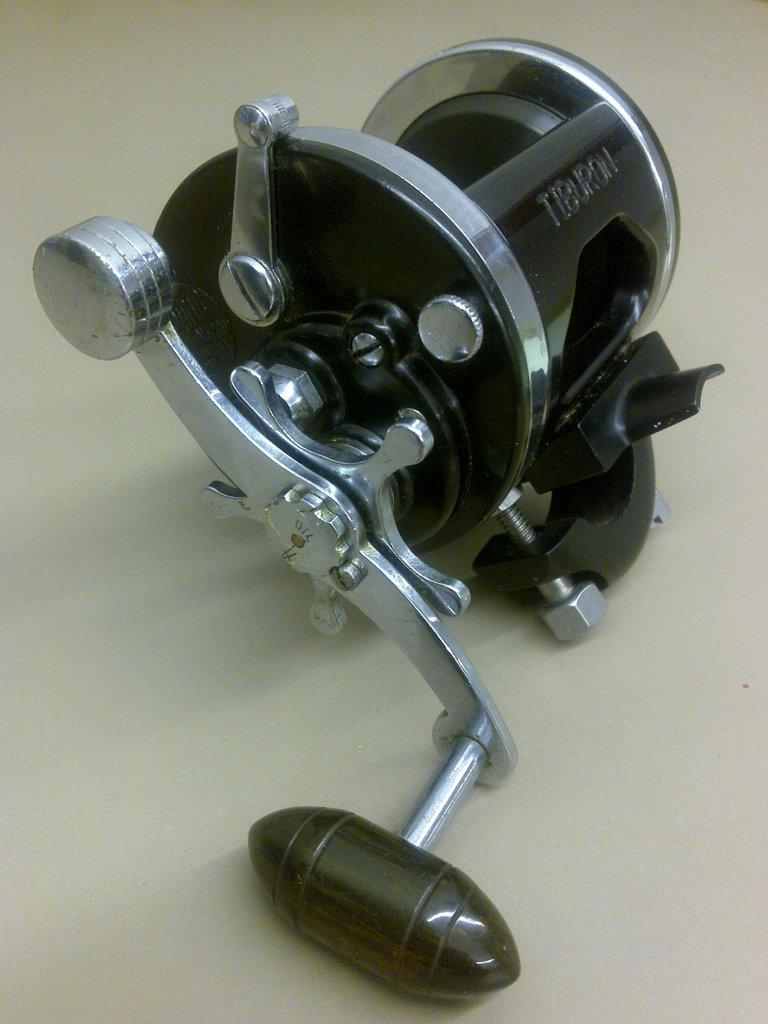What is the main subject of the image? There is an object in the center of the image. What type of hydrant is shown in the image? There is no hydrant present in the image; it only features an object in the center. 